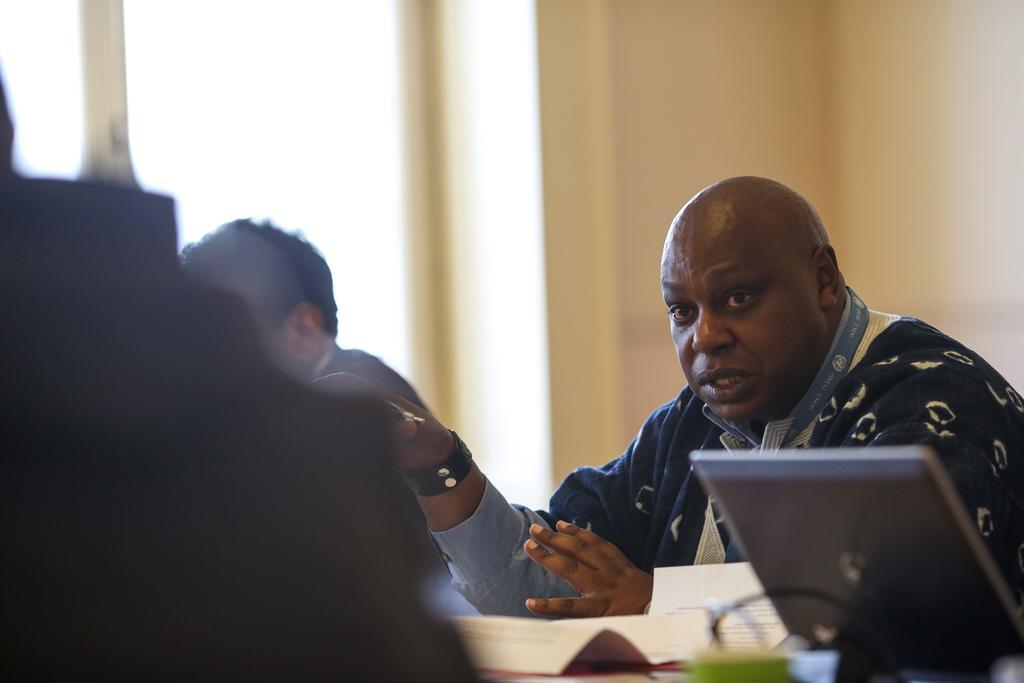Can you describe this image briefly? In this image there is a man sitting. He is wearing an identity card. In front of him there is a table. On the table there is a system. There are also papers on the table. Beside the person there is another man sitting. Behind them there is a wall. To the left there is a window to the wall. 